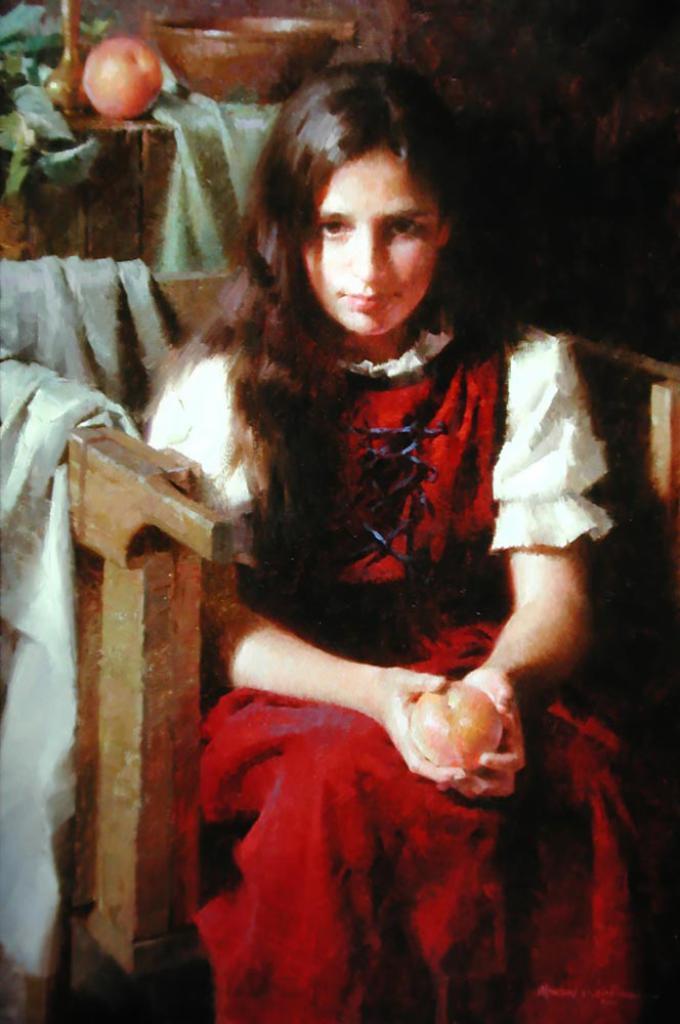Describe this image in one or two sentences. This picture shows a painting. We see girl seated on the chair and we see a fruit in her hands and a fruit on the table and a bowl and few leaves and a cloth on the chair. 